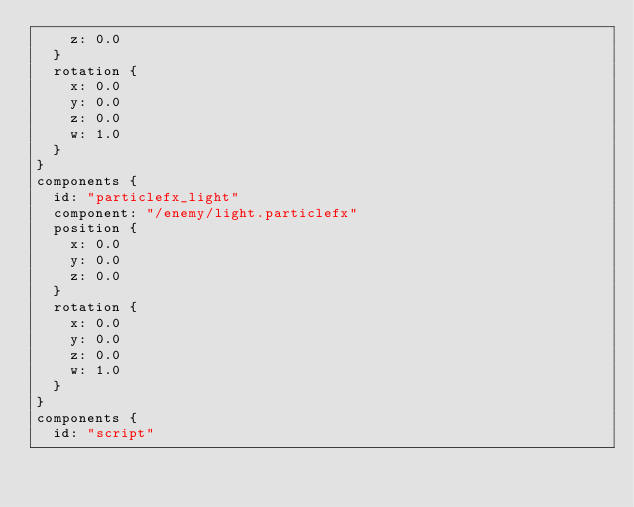<code> <loc_0><loc_0><loc_500><loc_500><_Go_>    z: 0.0
  }
  rotation {
    x: 0.0
    y: 0.0
    z: 0.0
    w: 1.0
  }
}
components {
  id: "particlefx_light"
  component: "/enemy/light.particlefx"
  position {
    x: 0.0
    y: 0.0
    z: 0.0
  }
  rotation {
    x: 0.0
    y: 0.0
    z: 0.0
    w: 1.0
  }
}
components {
  id: "script"</code> 